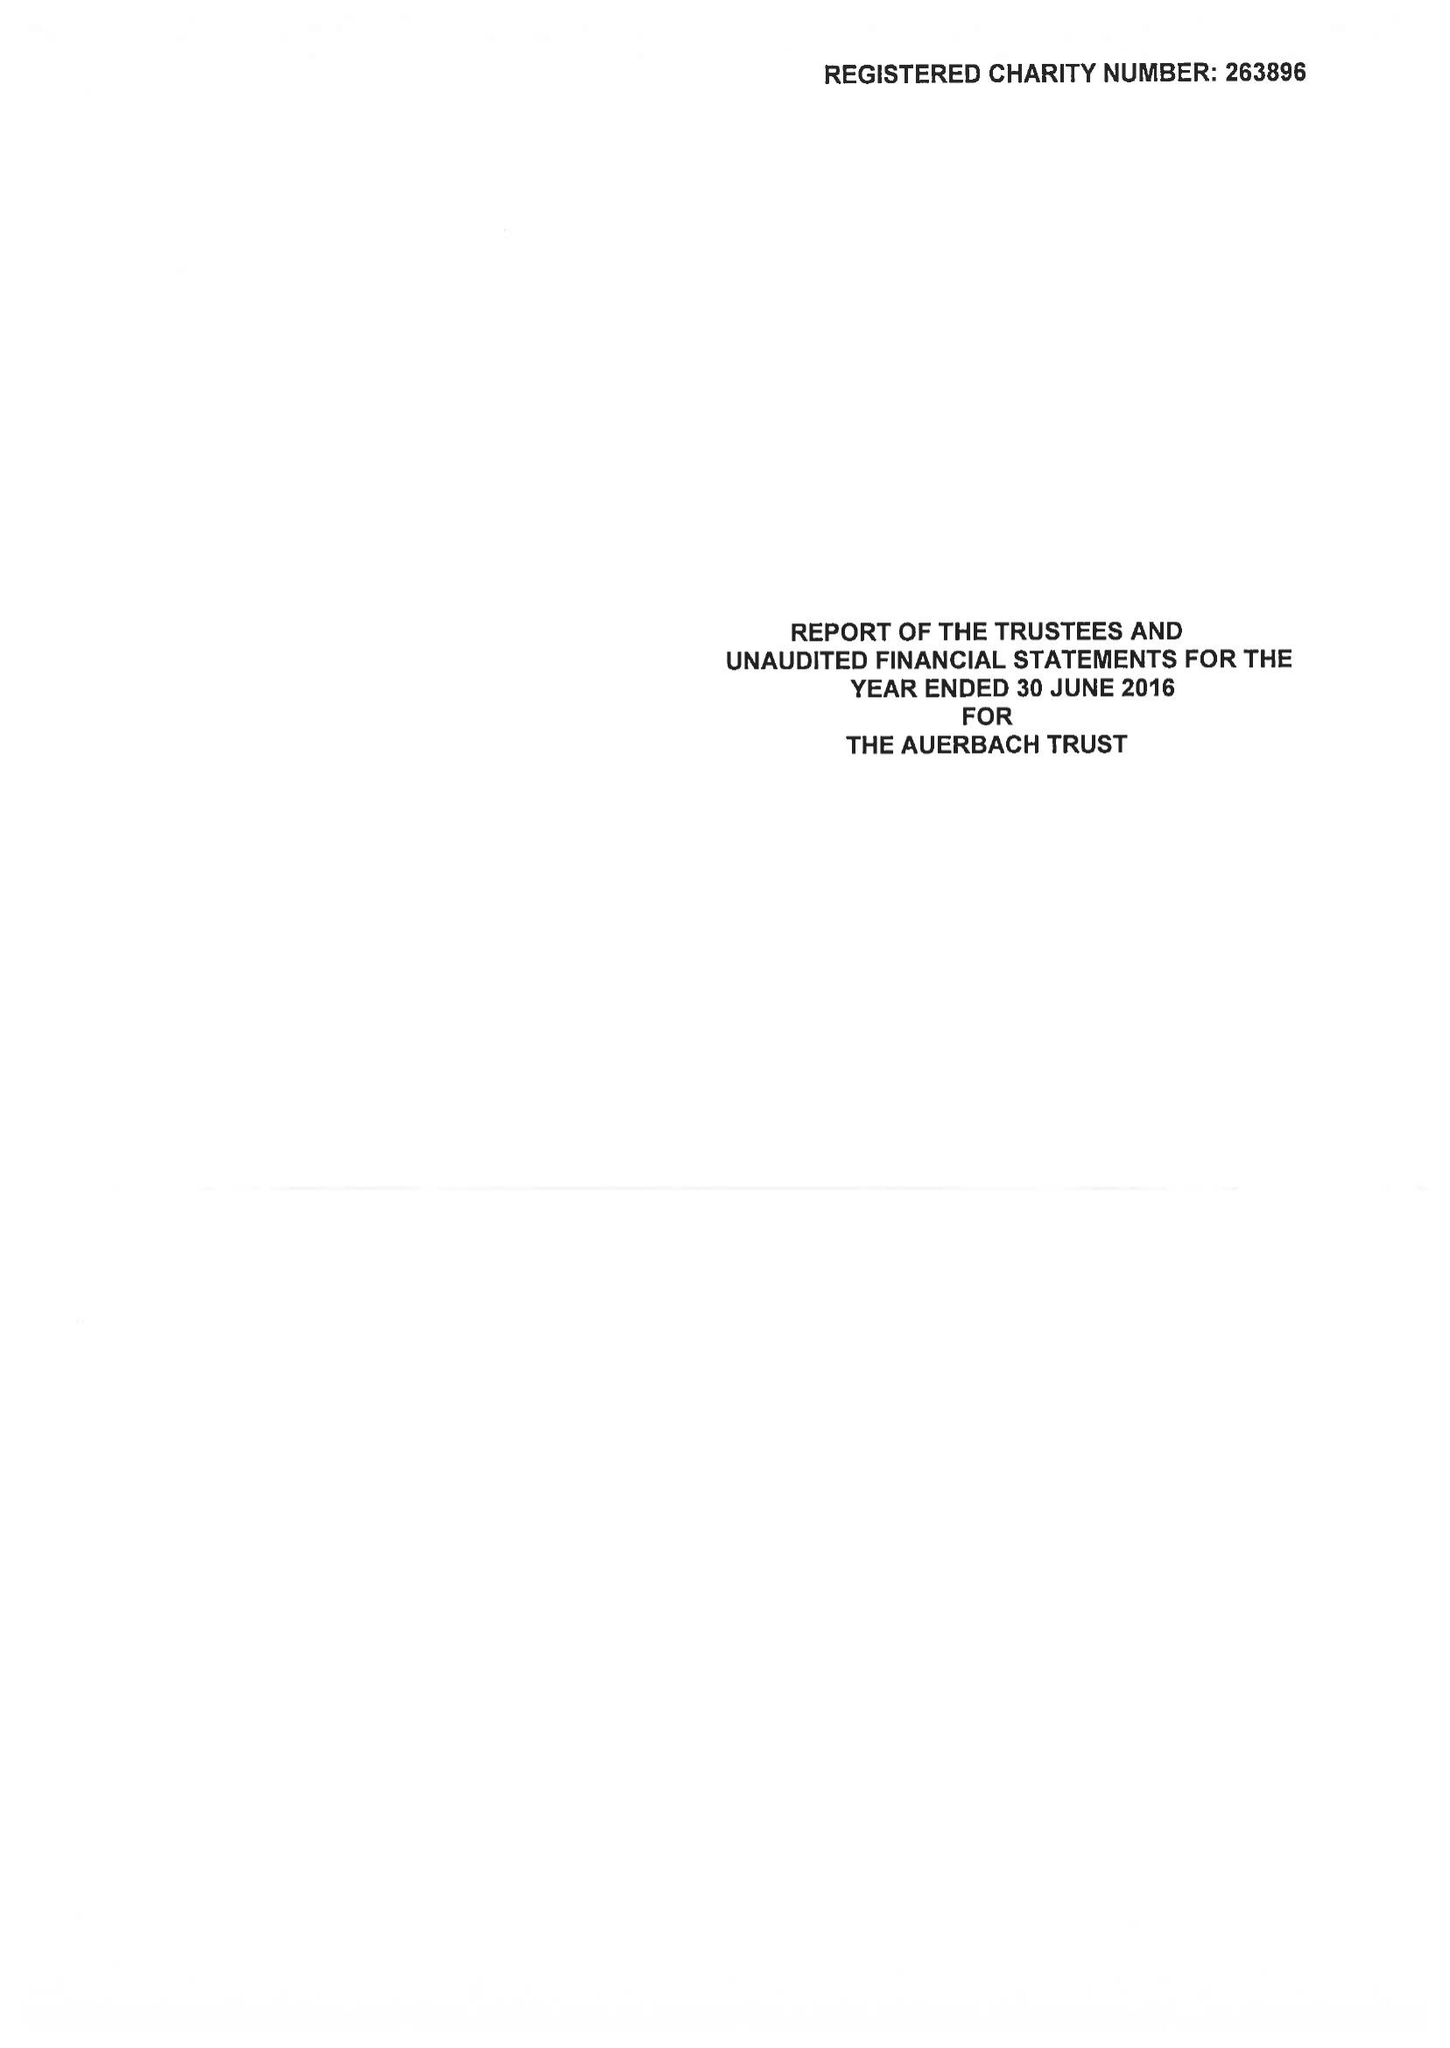What is the value for the income_annually_in_british_pounds?
Answer the question using a single word or phrase. 25345.00 